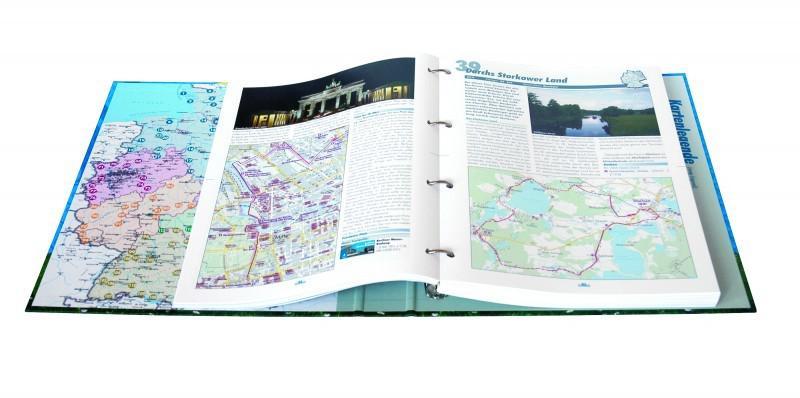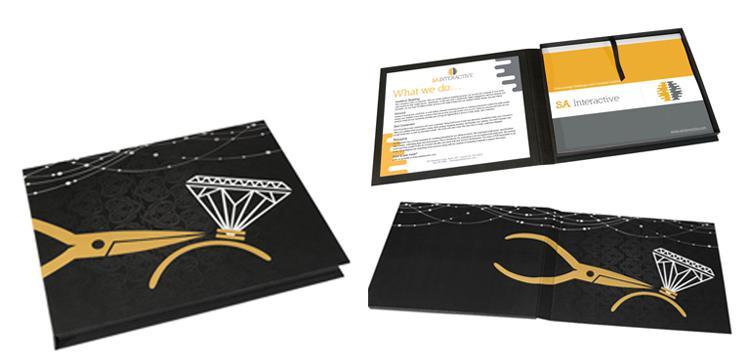The first image is the image on the left, the second image is the image on the right. For the images displayed, is the sentence "One of the binders itself, not the pages within, has maps as a design, on the visible part of the binder." factually correct? Answer yes or no. Yes. The first image is the image on the left, the second image is the image on the right. Examine the images to the left and right. Is the description "One of the binders has an interior pocket containing a calculator." accurate? Answer yes or no. No. 